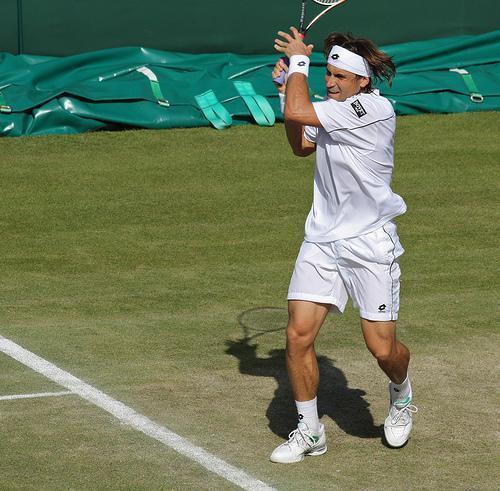How many people are there?
Give a very brief answer. 1. 